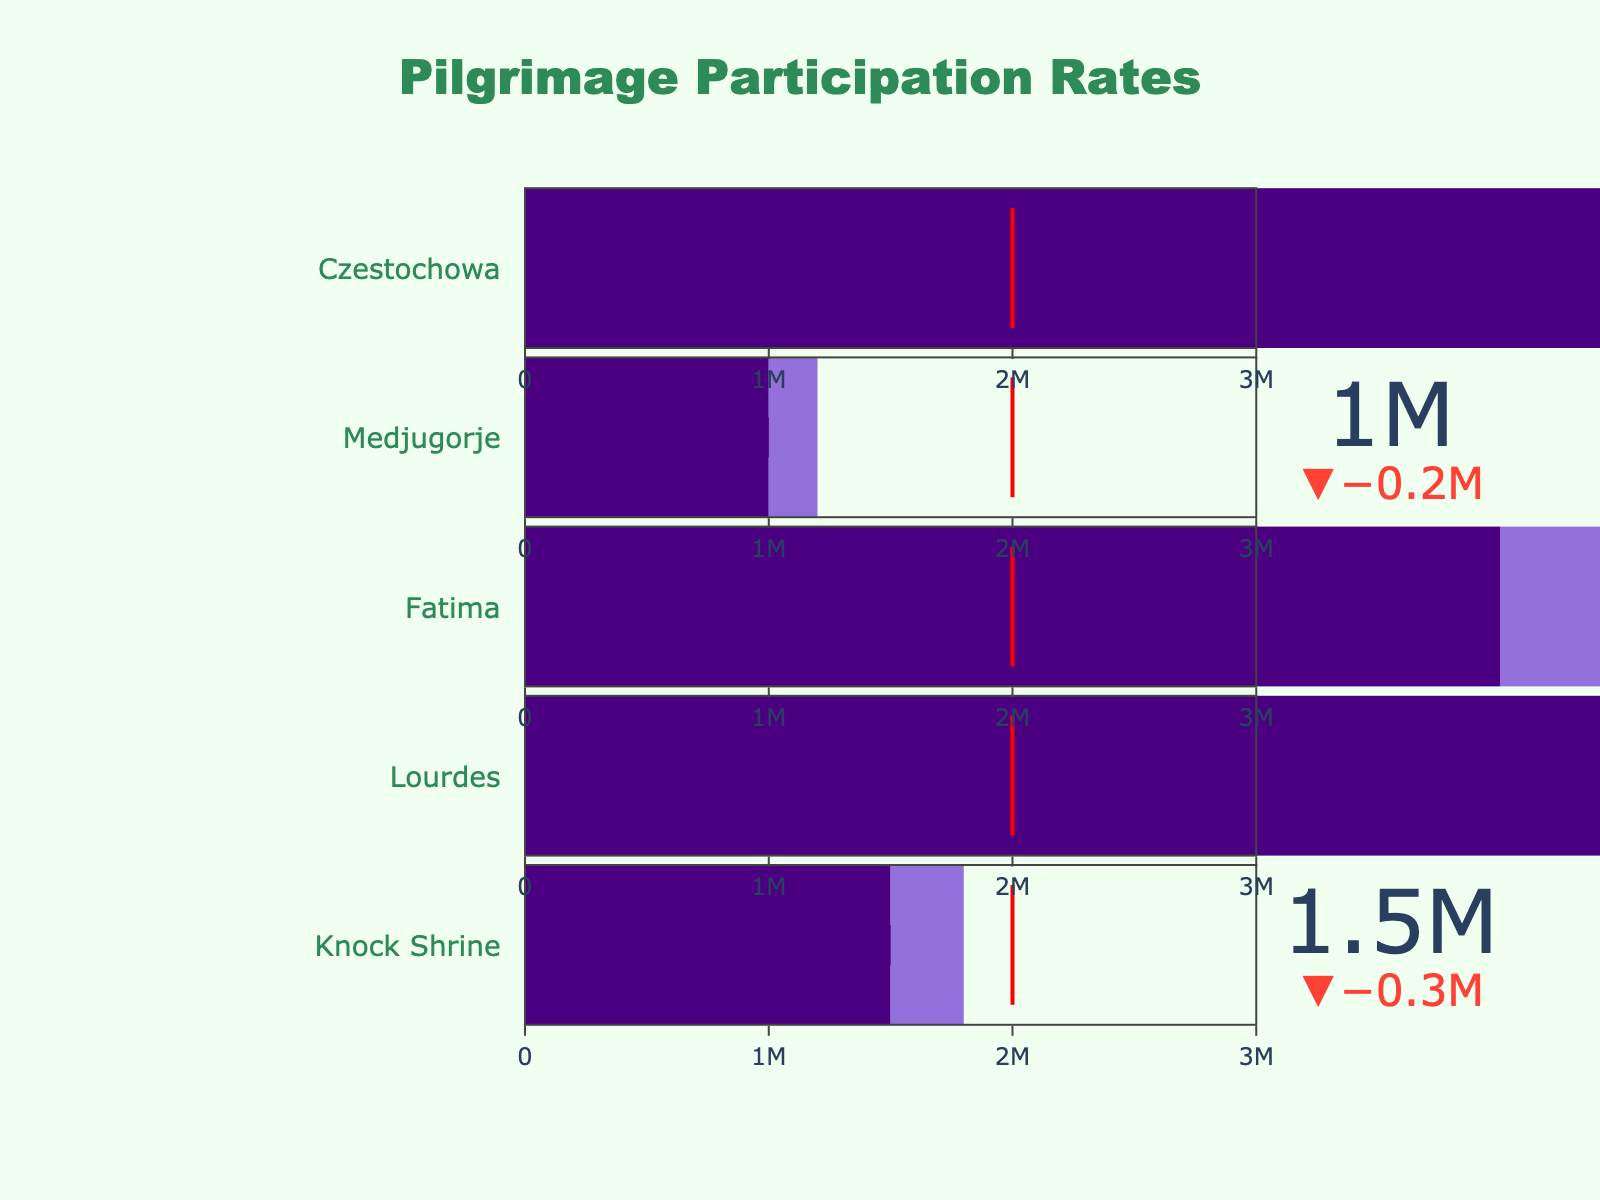what is the title of the figure? The title of the figure is displayed at the top in a larger font size and a specific color. According to the description, it is labeled "Pilgrimage Participation Rates".
Answer: Pilgrimage Participation Rates How many shrines are represented in the figure? To find this, count the number of distinct indicators shown for each shrine. According to the data, there are five shrines represented in the figure.
Answer: five What is the annual visitor count for Knock Shrine, and how does it compare to its target? The figure displays a specific count for "Annual Visitors" and a "Target" for each shrine. For Knock Shrine, the annual visitor count is 1,500,000, and the target is 1,800,000.
Answer: 1,500,000 visitors, below the target Which shrine receives the highest number of visitors annually and what is that number? Look at the value indicators for each shrine’s annual visitors. The highest value shown is for Lourdes, with 6,000,000 annual visitors.
Answer: Lourdes with 6,000,000 visitors Are there any shrines that have exceeded their target visitor count? Compare the value of "Annual Visitors" to the "Target" for each shrine. Lourdes meets its target (6,000,000 vs. 6,500,000), and other shrines do not exceed their targets.
Answer: No How does the annual visitor count for Knock Shrine compare to the European average? According to the figure, the European average visitor count is shown as a threshold line. Knock Shrine's annual count (1,500,000) is below the European average (2,000,000).
Answer: below Which shrine has the largest difference between its annual visitors and its target? Calculate the difference between "Annual Visitors" and "Target" for each shrine. Lourdes has the smallest difference, and Medjugorje has the largest difference (1,000,000 vs. 200,000).
Answer: Lourdes What is the European average threshold represented in the figure? The European average threshold is marked with a line in each gauge. According to the data, it is labeled as 2,000,000 visitors.
Answer: 2,000,000 Which shrine has the lowest annual visitor count, and what is that number? Identify the smallest value under "Annual Visitors" among all shrines. The lowest count is for Medjugorje with 1,000,000 annual visitors.
Answer: Medjugorje with 1,000,000 visitors What is the maximum visitor capacity for the shrines displayed in the figure? Look at the gauge’s range maximum as mentioned in the description for each shrine. The "Maximum" visitor capacity for all shrines is 3,000,000.
Answer: 3,000,000 